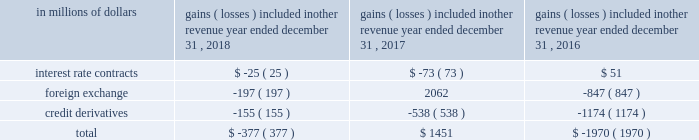For the years ended december a031 , 2018 , 2017 and 2016 , the amounts recognized in principal transactions in the consolidated statement of income related to derivatives not designated in a qualifying hedging relationship , as well as the underlying non-derivative instruments , are presented in note a06 to the consolidated financial statements .
Citigroup presents this disclosure by showing derivative gains and losses related to its trading activities together with gains and losses related to non-derivative instruments within the same trading portfolios , as this represents how these portfolios are risk managed .
The amounts recognized in other revenue in the consolidated statement of income related to derivatives not designated in a qualifying hedging relationship are shown below .
The table below does not include any offsetting gains ( losses ) on the economically hedged items to the extent that such amounts are also recorded in other revenue .
Gains ( losses ) included in other revenue year ended december 31 .
Accounting for derivative hedging citigroup accounts for its hedging activities in accordance with asc 815 , derivatives and hedging .
As a general rule , hedge accounting is permitted where the company is exposed to a particular risk , such as interest rate or foreign exchange risk , that causes changes in the fair value of an asset or liability or variability in the expected future cash flows of an existing asset , liability or a forecasted transaction that may affect earnings .
Derivative contracts hedging the risks associated with changes in fair value are referred to as fair value hedges , while contracts hedging the variability of expected future cash flows are cash flow hedges .
Hedges that utilize derivatives or debt instruments to manage the foreign exchange risk associated with equity investments in non-u.s.-dollar-functional- currency foreign subsidiaries ( net investment in a foreign operation ) are net investment hedges .
To qualify as an accounting hedge under the hedge accounting rules ( versus an economic hedge where hedge accounting is not applied ) , a hedging relationship must be highly effective in offsetting the risk designated as being hedged .
The hedging relationship must be formally documented at inception , detailing the particular risk management objective and strategy for the hedge .
This includes the item and risk ( s ) being hedged , the hedging instrument being used and how effectiveness will be assessed .
The effectiveness of these hedging relationships is evaluated at hedge inception and on an ongoing basis both on a retrospective and prospective basis , typically using quantitative measures of correlation , with hedge ineffectiveness measured and recorded in current earnings .
Hedge effectiveness assessment methodologies are performed in a similar manner for similar hedges , and are used consistently throughout the hedging relationships .
The assessment of effectiveness may exclude changes in the value of the hedged item that are unrelated to the risks being hedged and the changes in fair value of the derivative associated with time value .
Prior to january 1 , 2018 , these excluded items were recognized in current earnings for the hedging derivative , while changes in the value of a hedged item that were not related to the hedged risk were not recorded .
Upon adoption of asc 2017-12 , citi excludes changes in the cross currency basis associated with cross currency swaps from the assessment of hedge effectiveness and records it in other comprehensive income .
Discontinued hedge accounting a hedging instrument must be highly effective in accomplishing the hedge objective of offsetting either changes in the fair value or cash flows of the hedged item for the risk being hedged .
Management may voluntarily de-designate an accounting hedge at any time , but if a hedging relationship is not highly effective , it no longer qualifies for hedge accounting and must be de-designated .
Subsequent changes in the fair value of the derivative are recognized in other revenue or principal transactions , similar to trading derivatives , with no offset recorded related to the hedged item .
For fair value hedges , any changes in the fair value of the hedged item remain as part of the basis of the asset or liability and are ultimately realized as an element of the yield on the item .
For cash flow hedges , changes in fair value of the end-user derivative remain in accumulated other comprehensive income ( loss ) ( aoci ) and are included in the earnings of future periods when the forecasted hedged cash flows impact earnings .
However , if it becomes probable that some or all of the hedged forecasted transactions will not occur , any amounts that remain in aoci related to these transactions must be immediately reflected in other revenue .
The foregoing criteria are applied on a decentralized basis , consistent with the level at which market risk is managed , but are subject to various limits and controls .
The underlying asset , liability or forecasted transaction may be an individual item or a portfolio of similar items. .
What was the net change in gains from 2017 to 2018? 
Rationale: there was a net loss of -1828 from 2017 to 2018
Computations: (-377 - 1451)
Answer: -1828.0. 